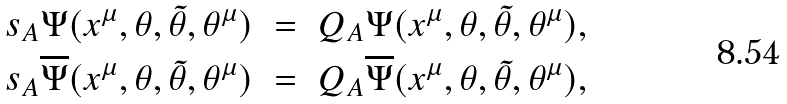<formula> <loc_0><loc_0><loc_500><loc_500>s _ { A } \Psi ( x ^ { \mu } , \theta , \tilde { \theta } , \theta ^ { \mu } ) \ & = \ Q _ { A } \Psi ( x ^ { \mu } , \theta , \tilde { \theta } , \theta ^ { \mu } ) , \\ s _ { A } \overline { \Psi } ( x ^ { \mu } , \theta , \tilde { \theta } , \theta ^ { \mu } ) \ & = \ Q _ { A } \overline { \Psi } ( x ^ { \mu } , \theta , \tilde { \theta } , \theta ^ { \mu } ) ,</formula> 